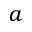Convert formula to latex. <formula><loc_0><loc_0><loc_500><loc_500>a</formula> 